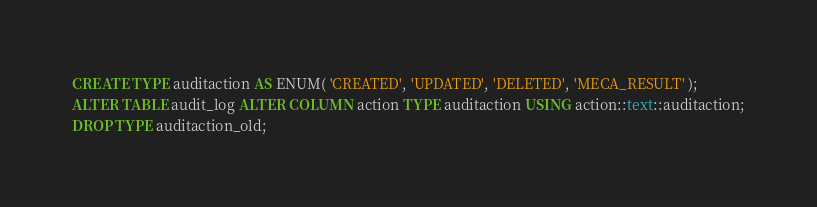Convert code to text. <code><loc_0><loc_0><loc_500><loc_500><_SQL_>CREATE TYPE auditaction AS ENUM( 'CREATED', 'UPDATED', 'DELETED', 'MECA_RESULT' );
ALTER TABLE audit_log ALTER COLUMN action TYPE auditaction USING action::text::auditaction;
DROP TYPE auditaction_old;</code> 